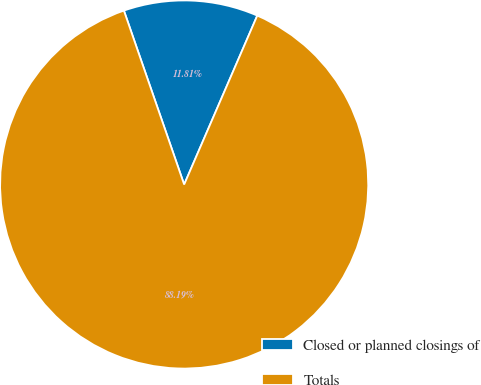Convert chart. <chart><loc_0><loc_0><loc_500><loc_500><pie_chart><fcel>Closed or planned closings of<fcel>Totals<nl><fcel>11.81%<fcel>88.19%<nl></chart> 